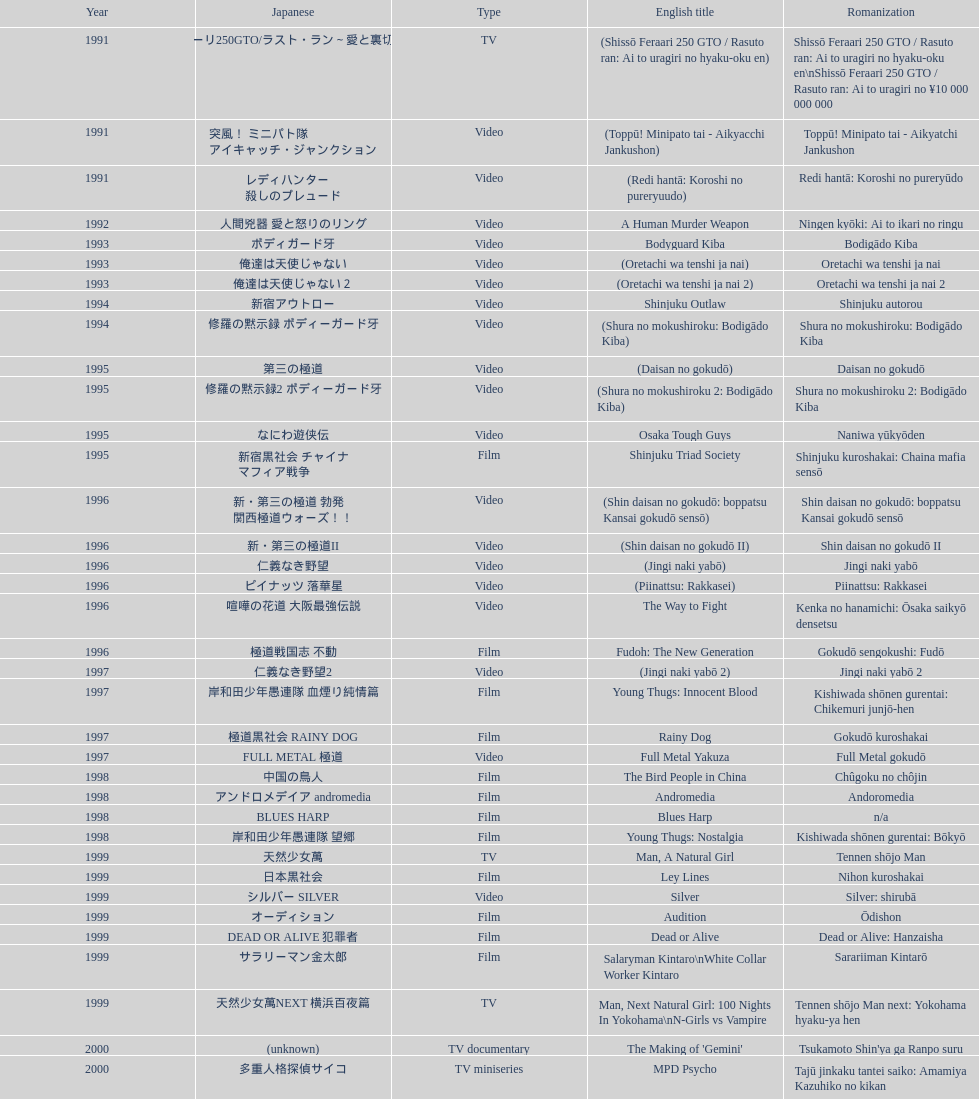What is takashi miike's work with the least amount of years since release? The Mole Song: Undercover Agent Reiji. Would you be able to parse every entry in this table? {'header': ['Year', 'Japanese', 'Type', 'English title', 'Romanization'], 'rows': [['1991', '疾走フェラーリ250GTO/ラスト・ラン～愛と裏切りの百億円', 'TV', '(Shissō Feraari 250 GTO / Rasuto ran: Ai to uragiri no hyaku-oku en)', 'Shissō Feraari 250 GTO / Rasuto ran: Ai to uragiri no hyaku-oku en\\nShissō Feraari 250 GTO / Rasuto ran: Ai to uragiri no ¥10 000 000 000'], ['1991', '突風！ ミニパト隊 アイキャッチ・ジャンクション', 'Video', '(Toppū! Minipato tai - Aikyacchi Jankushon)', 'Toppū! Minipato tai - Aikyatchi Jankushon'], ['1991', 'レディハンター 殺しのプレュード', 'Video', '(Redi hantā: Koroshi no pureryuudo)', 'Redi hantā: Koroshi no pureryūdo'], ['1992', '人間兇器 愛と怒りのリング', 'Video', 'A Human Murder Weapon', 'Ningen kyōki: Ai to ikari no ringu'], ['1993', 'ボディガード牙', 'Video', 'Bodyguard Kiba', 'Bodigādo Kiba'], ['1993', '俺達は天使じゃない', 'Video', '(Oretachi wa tenshi ja nai)', 'Oretachi wa tenshi ja nai'], ['1993', '俺達は天使じゃない２', 'Video', '(Oretachi wa tenshi ja nai 2)', 'Oretachi wa tenshi ja nai 2'], ['1994', '新宿アウトロー', 'Video', 'Shinjuku Outlaw', 'Shinjuku autorou'], ['1994', '修羅の黙示録 ボディーガード牙', 'Video', '(Shura no mokushiroku: Bodigādo Kiba)', 'Shura no mokushiroku: Bodigādo Kiba'], ['1995', '第三の極道', 'Video', '(Daisan no gokudō)', 'Daisan no gokudō'], ['1995', '修羅の黙示録2 ボディーガード牙', 'Video', '(Shura no mokushiroku 2: Bodigādo Kiba)', 'Shura no mokushiroku 2: Bodigādo Kiba'], ['1995', 'なにわ遊侠伝', 'Video', 'Osaka Tough Guys', 'Naniwa yūkyōden'], ['1995', '新宿黒社会 チャイナ マフィア戦争', 'Film', 'Shinjuku Triad Society', 'Shinjuku kuroshakai: Chaina mafia sensō'], ['1996', '新・第三の極道 勃発 関西極道ウォーズ！！', 'Video', '(Shin daisan no gokudō: boppatsu Kansai gokudō sensō)', 'Shin daisan no gokudō: boppatsu Kansai gokudō sensō'], ['1996', '新・第三の極道II', 'Video', '(Shin daisan no gokudō II)', 'Shin daisan no gokudō II'], ['1996', '仁義なき野望', 'Video', '(Jingi naki yabō)', 'Jingi naki yabō'], ['1996', 'ピイナッツ 落華星', 'Video', '(Piinattsu: Rakkasei)', 'Piinattsu: Rakkasei'], ['1996', '喧嘩の花道 大阪最強伝説', 'Video', 'The Way to Fight', 'Kenka no hanamichi: Ōsaka saikyō densetsu'], ['1996', '極道戦国志 不動', 'Film', 'Fudoh: The New Generation', 'Gokudō sengokushi: Fudō'], ['1997', '仁義なき野望2', 'Video', '(Jingi naki yabō 2)', 'Jingi naki yabō 2'], ['1997', '岸和田少年愚連隊 血煙り純情篇', 'Film', 'Young Thugs: Innocent Blood', 'Kishiwada shōnen gurentai: Chikemuri junjō-hen'], ['1997', '極道黒社会 RAINY DOG', 'Film', 'Rainy Dog', 'Gokudō kuroshakai'], ['1997', 'FULL METAL 極道', 'Video', 'Full Metal Yakuza', 'Full Metal gokudō'], ['1998', '中国の鳥人', 'Film', 'The Bird People in China', 'Chûgoku no chôjin'], ['1998', 'アンドロメデイア andromedia', 'Film', 'Andromedia', 'Andoromedia'], ['1998', 'BLUES HARP', 'Film', 'Blues Harp', 'n/a'], ['1998', '岸和田少年愚連隊 望郷', 'Film', 'Young Thugs: Nostalgia', 'Kishiwada shōnen gurentai: Bōkyō'], ['1999', '天然少女萬', 'TV', 'Man, A Natural Girl', 'Tennen shōjo Man'], ['1999', '日本黒社会', 'Film', 'Ley Lines', 'Nihon kuroshakai'], ['1999', 'シルバー SILVER', 'Video', 'Silver', 'Silver: shirubā'], ['1999', 'オーディション', 'Film', 'Audition', 'Ōdishon'], ['1999', 'DEAD OR ALIVE 犯罪者', 'Film', 'Dead or Alive', 'Dead or Alive: Hanzaisha'], ['1999', 'サラリーマン金太郎', 'Film', 'Salaryman Kintaro\\nWhite Collar Worker Kintaro', 'Sarariiman Kintarō'], ['1999', '天然少女萬NEXT 横浜百夜篇', 'TV', 'Man, Next Natural Girl: 100 Nights In Yokohama\\nN-Girls vs Vampire', 'Tennen shōjo Man next: Yokohama hyaku-ya hen'], ['2000', '(unknown)', 'TV documentary', "The Making of 'Gemini'", "Tsukamoto Shin'ya ga Ranpo suru"], ['2000', '多重人格探偵サイコ', 'TV miniseries', 'MPD Psycho', 'Tajū jinkaku tantei saiko: Amamiya Kazuhiko no kikan'], ['2000', '漂流街 THE HAZARD CITY', 'Film', 'The City of Lost Souls\\nThe City of Strangers\\nThe Hazard City', 'Hyōryū-gai'], ['2000', '天国から来た男たち', 'Film', 'The Guys from Paradise', 'Tengoku kara kita otoko-tachi'], ['2000', 'DEAD OR ALIVE 2 逃亡者', 'Film', 'Dead or Alive 2: Birds\\nDead or Alive 2: Runaway', 'Dead or Alive 2: Tōbōsha'], ['2001', '鞠智城物語 防人たちの唄', 'Film', '(Kikuchi-jō monogatari: sakimori-tachi no uta)', 'Kikuchi-jō monogatari: sakimori-tachi no uta'], ['2001', '隧穴幻想 トンカラリン夢伝説', 'Film', '(Zuiketsu gensō: Tonkararin yume densetsu)', 'Zuiketsu gensō: Tonkararin yume densetsu'], ['2001', 'FAMILY', 'Film', 'Family', 'n/a'], ['2001', 'ビジターQ', 'Video', 'Visitor Q', 'Bijitā Q'], ['2001', '殺し屋1', 'Film', 'Ichi the Killer', 'Koroshiya 1'], ['2001', '荒ぶる魂たち', 'Film', 'Agitator', 'Araburu tamashii-tachi'], ['2001', 'カタクリ家の幸福', 'Film', 'The Happiness of the Katakuris', 'Katakuri-ke no kōfuku'], ['2002', 'DEAD OR ALIVE FINAL', 'Film', 'Dead or Alive: Final', 'n/a'], ['2002', 'おんな 国衆一揆', '(unknown)', '(Onna kunishū ikki)', 'Onna kunishū ikki'], ['2002', 'SABU さぶ', 'TV', 'Sabu', 'Sabu'], ['2002', '新・仁義の墓場', 'Film', 'Graveyard of Honor', 'Shin jingi no hakaba'], ['2002', '金融破滅ニッポン 桃源郷の人々', 'Film', 'Shangri-La', "Kin'yū hametsu Nippon: Tōgenkyō no hito-bito"], ['2002', 'パンドーラ', 'Music video', 'Pandōra', 'Pandōra'], ['2002', '実録・安藤昇侠道（アウトロー）伝 烈火', 'Film', 'Deadly Outlaw: Rekka\\nViolent Fire', 'Jitsuroku Andō Noboru kyōdō-den: Rekka'], ['2002', 'パートタイム探偵', 'TV series', 'Pāto-taimu tantei', 'Pāto-taimu tantei'], ['2003', '許されざる者', 'Film', 'The Man in White', 'Yurusarezaru mono'], ['2003', '極道恐怖大劇場 牛頭 GOZU', 'Film', 'Gozu', 'Gokudō kyōfu dai-gekijō: Gozu'], ['2003', '鬼哭 kikoku', 'Video', 'Yakuza Demon', 'Kikoku'], ['2003', '交渉人', 'TV', 'Kōshōnin', 'Kōshōnin'], ['2003', '着信アリ', 'Film', "One Missed Call\\nYou've Got a Call", 'Chakushin Ari'], ['2004', 'ゼブラーマン', 'Film', 'Zebraman', 'Zeburāman'], ['2004', 'パートタイム探偵2', 'TV', 'Pāto-taimu tantei 2', 'Pāto-taimu tantei 2'], ['2004', 'BOX（『美しい夜、残酷な朝』）', 'Segment in feature film', 'Box segment in Three... Extremes', 'Saam gaang yi'], ['2004', 'IZO', 'Film', 'Izo', 'IZO'], ['2005', 'ウルトラマンマックス', 'Episodes 15 and 16 from TV tokusatsu series', 'Ultraman Max', 'Urutoraman Makkusu'], ['2005', '妖怪大戦争', 'Film', 'The Great Yokai War', 'Yokai Daisenso'], ['2006', '46億年の恋', 'Film', 'Big Bang Love, Juvenile A\\n4.6 Billion Years of Love', '46-okunen no koi'], ['2006', 'WARU', 'Film', 'Waru', 'Waru'], ['2006', 'インプリント ～ぼっけえ、きょうてえ～', 'TV episode', 'Imprint episode from Masters of Horror', 'Inpurinto ~bokke kyote~'], ['2006', '', 'Video', 'Waru: kanketsu-hen', 'Waru: kanketsu-hen'], ['2006', '太陽の傷', 'Film', 'Sun Scarred', 'Taiyo no kizu'], ['2007', 'スキヤキ・ウエスタン ジャンゴ', 'Film', 'Sukiyaki Western Django', 'Sukiyaki wesutān jango'], ['2007', 'クローズZERO', 'Film', 'Crows Zero', 'Kurōzu Zero'], ['2007', '龍が如く 劇場版', 'Film', 'Like a Dragon', 'Ryu ga Gotoku Gekijōban'], ['2007', '座頭市', 'Stageplay', 'Zatoichi', 'Zatōichi'], ['2007', '探偵物語', 'Film', 'Detective Story', 'Tantei monogatari'], ['2008', '神様のパズル', 'Film', "God's Puzzle", 'Kamisama no pazuru'], ['2008', 'ケータイ捜査官7', 'TV', 'K-tai Investigator 7', 'Keitai Sōsakan 7'], ['2009', 'ヤッターマン', 'Film', 'Yatterman', 'Yattaaman'], ['2009', 'クローズZERO 2', 'Film', 'Crows Zero 2', 'Kurōzu Zero 2'], ['2010', '十三人の刺客', 'Film', 'Thirteen Assassins', 'Jûsan-nin no shikaku'], ['2010', 'ゼブラーマン -ゼブラシティの逆襲', 'Film', 'Zebraman 2: Attack on Zebra City', 'Zeburāman -Zebura Shiti no Gyakushū'], ['2011', '忍たま乱太郎', 'Film', 'Ninja Kids!!!', 'Nintama Rantarō'], ['2011', '一命', 'Film', 'Hara-Kiri: Death of a Samurai', 'Ichimei'], ['2012', '逆転裁判', 'Film', 'Ace Attorney', 'Gyakuten Saiban'], ['2012', '愛と誠', 'Film', "For Love's Sake", 'Ai to makoto'], ['2012', '悪の教典', 'Film', 'Lesson of the Evil', 'Aku no Kyōten'], ['2013', '藁の楯', 'Film', 'Shield of Straw', 'Wara no Tate'], ['2013', '土竜の唄\u3000潜入捜査官 REIJI', 'Film', 'The Mole Song: Undercover Agent Reiji', 'Mogura no uta – sennyu sosakan: Reiji']]} 